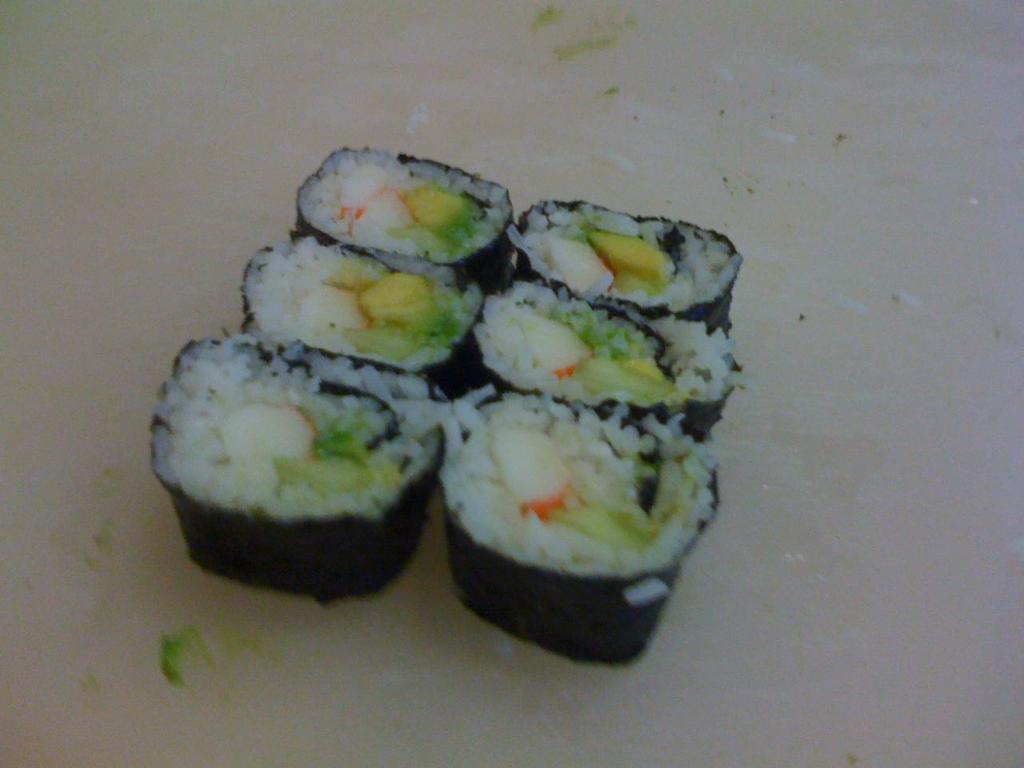How would you summarize this image in a sentence or two? In this image, we can see some food on the white surface. 